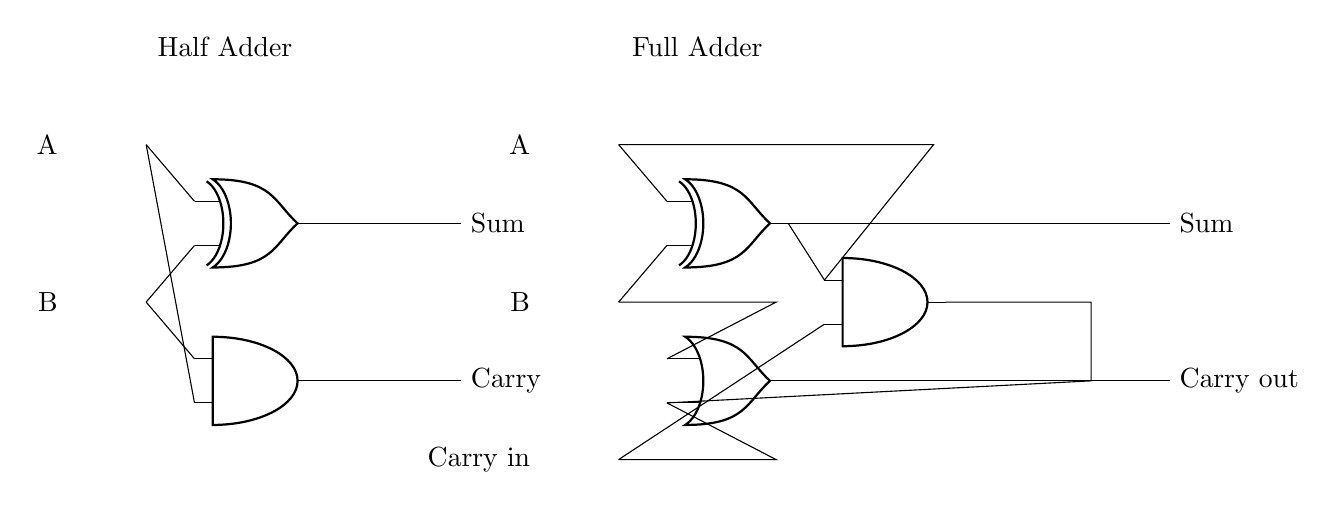What components are present in the circuit? The circuit includes a half adder and a full adder, which consist of AND gates, XOR gates, and an OR gate. These components are identified visually by their symbols in the diagram.
Answer: Half Adder, Full Adder What is the output of the half adder? The output of the half adder consists of two signals: the Sum and the Carry. The Sum is produced by the XOR gate, and the Carry is produced by the AND gate.
Answer: Sum, Carry How many inputs does the full adder have? The full adder has three inputs: two for the binary numbers A and B, and one for the Carry in. This can be determined by counting the input lines leading into the components in the full adder section.
Answer: Three What does the XOR gate in the full adder produce? The XOR gate in the full adder calculates the Sum of the two inputs A and B. It outputs a signal based on the rule that the output is high if an odd number of inputs are high.
Answer: Sum How does the carry output of the full adder relate to its inputs? The carry output of the full adder comes from the combination of inputs A, B, and Carry in. Specifically, it is produced by the OR gate that combines the outputs of two AND gates which detect conditions for a carry to occur.
Answer: Logical combination of inputs What does the term "Carry in" refer to in this context? "Carry in" refers to the additional input that represents any carry from a previous less significant bit during addition. It is provided to allow continued binary arithmetic operations across multiple bits.
Answer: Previous carry input 